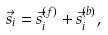Convert formula to latex. <formula><loc_0><loc_0><loc_500><loc_500>\vec { s } _ { i } = \vec { s } ^ { ( f ) } _ { i } + \vec { s } ^ { ( b ) } _ { i } ,</formula> 